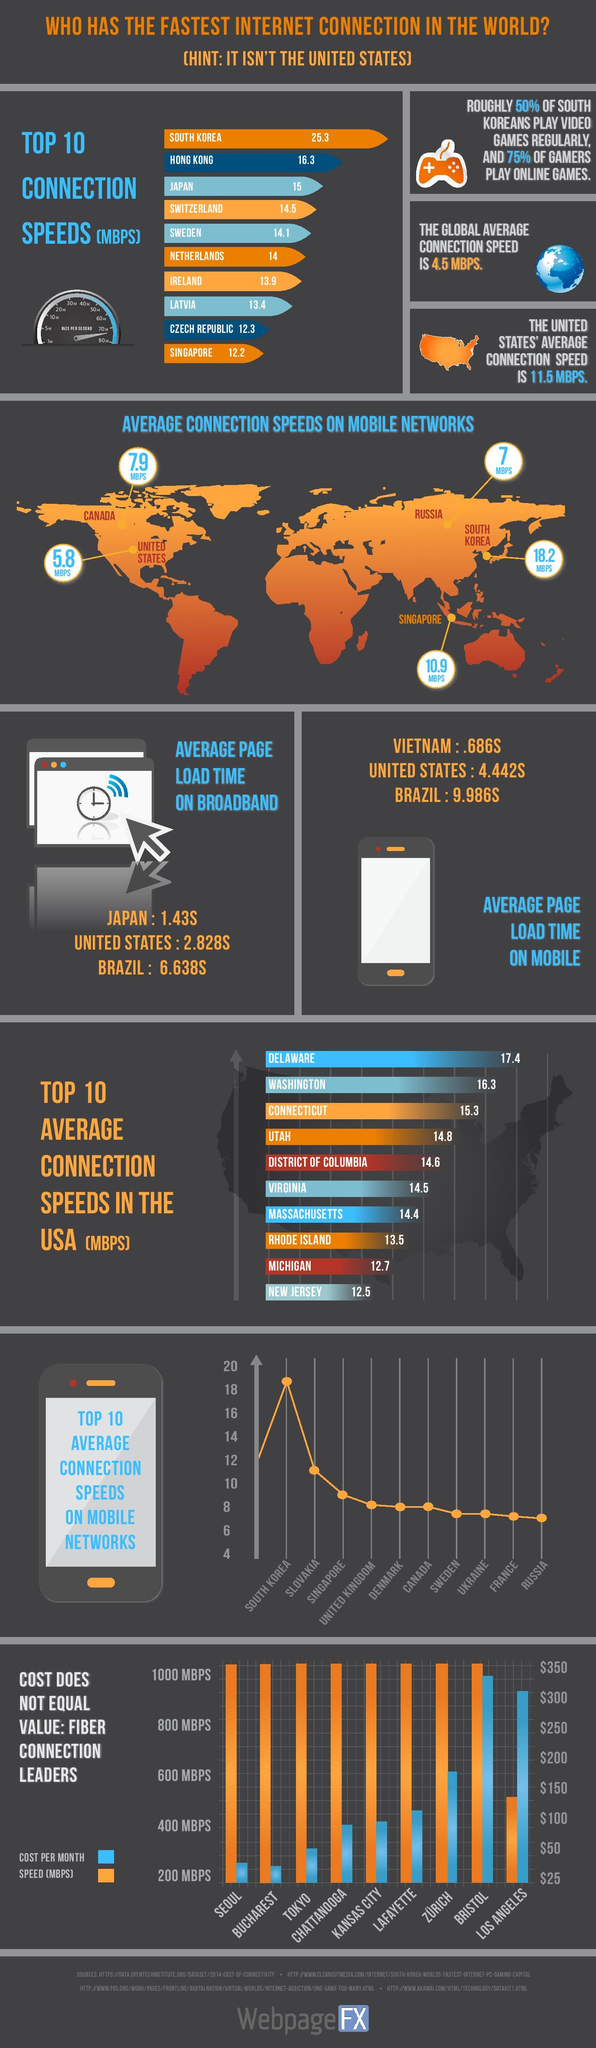List a handful of essential elements in this visual. The average page load time in Japan is significantly faster than the US, by 1.398 seconds. Three cities, Seoul, Bucharest, and Tokyo, offer internet connections for less than $50 per month, providing residents and visitors with affordable and accessible digital connectivity. According to the bar chart, Los Angeles has the lowest connection speed but also has the highest cost per month. The city with the highest internet speed of 1000 Mbps and a cost above $300 is Bristol, according to the bar chart. The global average connection speed is 20.8 MBPS, while the country with the highest speed is X. 